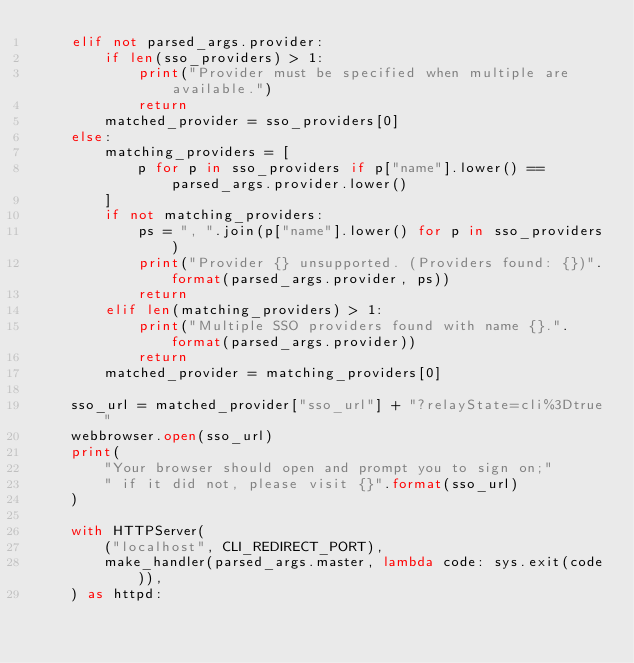<code> <loc_0><loc_0><loc_500><loc_500><_Python_>    elif not parsed_args.provider:
        if len(sso_providers) > 1:
            print("Provider must be specified when multiple are available.")
            return
        matched_provider = sso_providers[0]
    else:
        matching_providers = [
            p for p in sso_providers if p["name"].lower() == parsed_args.provider.lower()
        ]
        if not matching_providers:
            ps = ", ".join(p["name"].lower() for p in sso_providers)
            print("Provider {} unsupported. (Providers found: {})".format(parsed_args.provider, ps))
            return
        elif len(matching_providers) > 1:
            print("Multiple SSO providers found with name {}.".format(parsed_args.provider))
            return
        matched_provider = matching_providers[0]

    sso_url = matched_provider["sso_url"] + "?relayState=cli%3Dtrue"
    webbrowser.open(sso_url)
    print(
        "Your browser should open and prompt you to sign on;"
        " if it did not, please visit {}".format(sso_url)
    )

    with HTTPServer(
        ("localhost", CLI_REDIRECT_PORT),
        make_handler(parsed_args.master, lambda code: sys.exit(code)),
    ) as httpd:</code> 